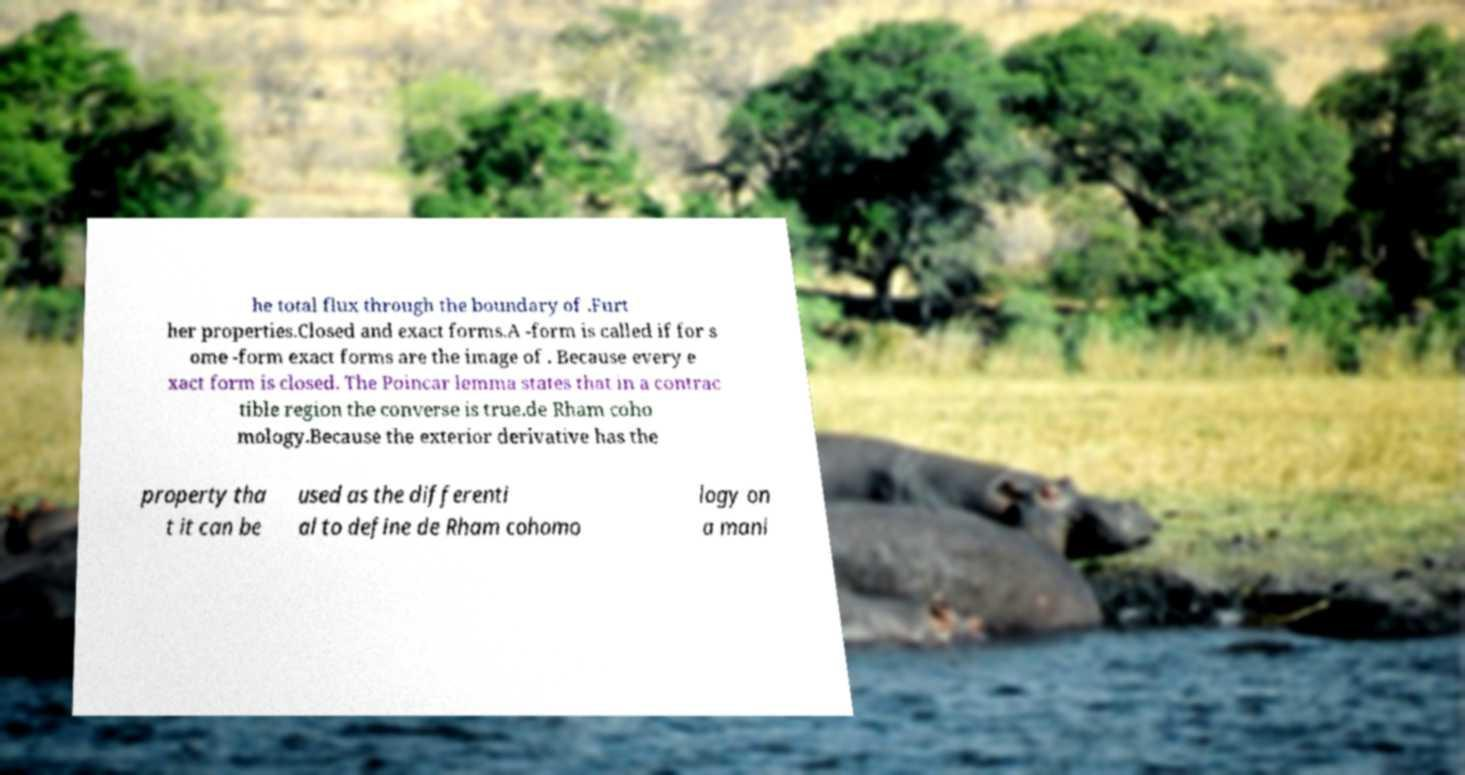Please read and relay the text visible in this image. What does it say? he total flux through the boundary of .Furt her properties.Closed and exact forms.A -form is called if for s ome -form exact forms are the image of . Because every e xact form is closed. The Poincar lemma states that in a contrac tible region the converse is true.de Rham coho mology.Because the exterior derivative has the property tha t it can be used as the differenti al to define de Rham cohomo logy on a mani 